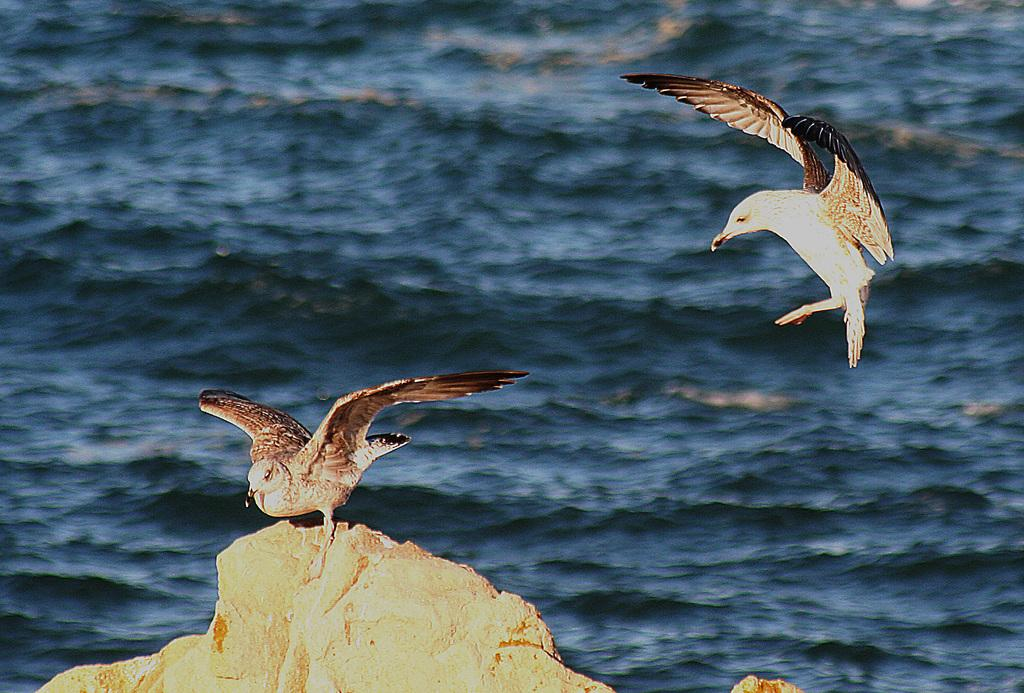What is the main subject of the image? There is a bird on a rock in the image. Can you describe another bird in the image? There is another bird flying in the air in the image. What can be seen in the background of the image? There is water visible in the background of the image. What type of treatment is the bird on the rock receiving? There is no indication in the image that the bird on the rock is receiving any treatment. 